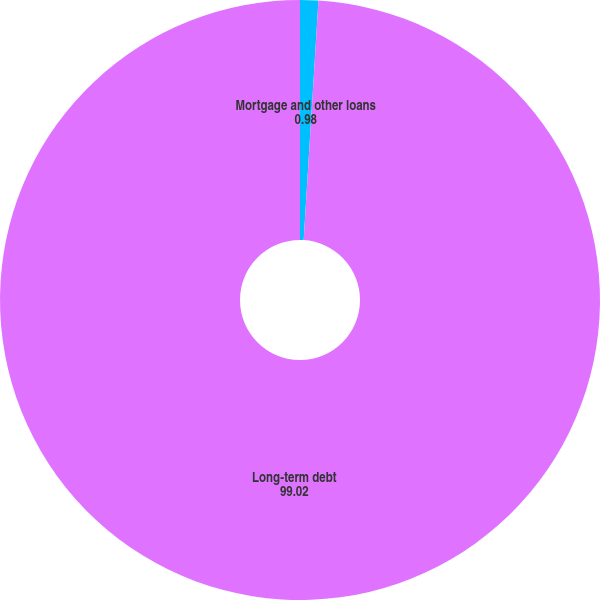<chart> <loc_0><loc_0><loc_500><loc_500><pie_chart><fcel>Mortgage and other loans<fcel>Long-term debt<nl><fcel>0.98%<fcel>99.02%<nl></chart> 